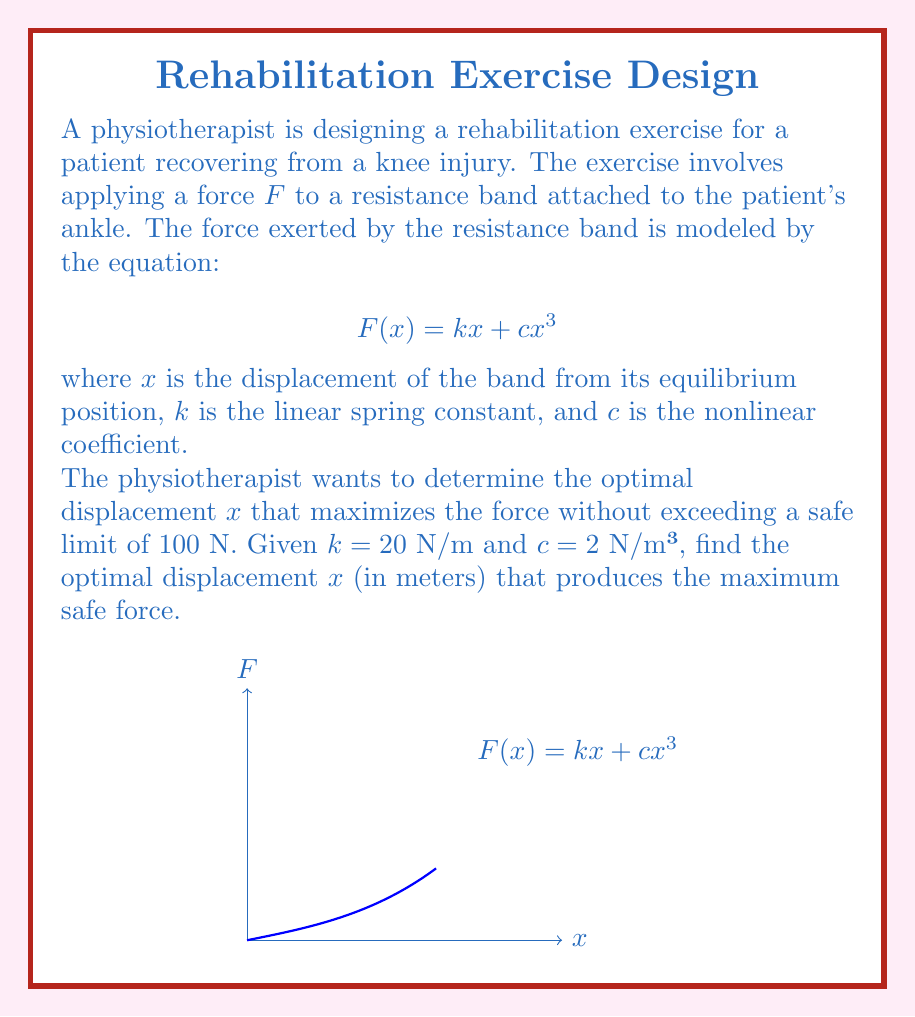Can you answer this question? To solve this problem, we need to follow these steps:

1) The force function is given by $F(x) = kx + cx^3$ with $k = 20$ N/m and $c = 2$ N/m³.

2) We want to find the maximum value of $F(x)$ that doesn't exceed 100 N. This occurs when $F(x) = 100$ N.

3) Let's set up the equation:

   $$100 = 20x + 2x^3$$

4) Rearrange the equation:

   $$2x^3 + 20x - 100 = 0$$

5) This is a cubic equation. It can be solved using the cubic formula, but a numerical method like Newton-Raphson would be more practical. Using a calculator or computer algebra system, we find that the positive real solution to this equation is approximately $x ≈ 1.9081$ m.

6) To verify this is indeed the maximum safe displacement, we can check the derivative of $F(x)$:

   $$F'(x) = k + 3cx^2 = 20 + 6x^2$$

   At $x ≈ 1.9081$, $F'(x) > 0$, confirming that $F(x)$ is still increasing at this point.

7) Therefore, the optimal displacement that produces the maximum safe force is approximately 1.9081 meters.
Answer: $x ≈ 1.9081$ m 